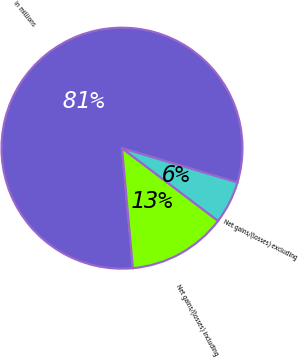<chart> <loc_0><loc_0><loc_500><loc_500><pie_chart><fcel>in millions<fcel>Net gains/(losses) including<fcel>Net gains/(losses) excluding<nl><fcel>81.04%<fcel>13.25%<fcel>5.71%<nl></chart> 